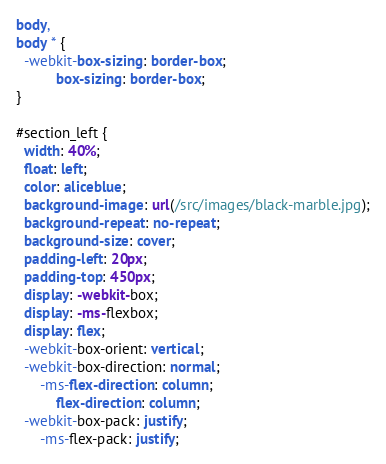Convert code to text. <code><loc_0><loc_0><loc_500><loc_500><_CSS_>body,
body * {
  -webkit-box-sizing: border-box;
          box-sizing: border-box;
}

#section_left {
  width: 40%;
  float: left;
  color: aliceblue;
  background-image: url(/src/images/black-marble.jpg);
  background-repeat: no-repeat;
  background-size: cover;
  padding-left: 20px;
  padding-top: 450px;
  display: -webkit-box;
  display: -ms-flexbox;
  display: flex;
  -webkit-box-orient: vertical;
  -webkit-box-direction: normal;
      -ms-flex-direction: column;
          flex-direction: column;
  -webkit-box-pack: justify;
      -ms-flex-pack: justify;</code> 